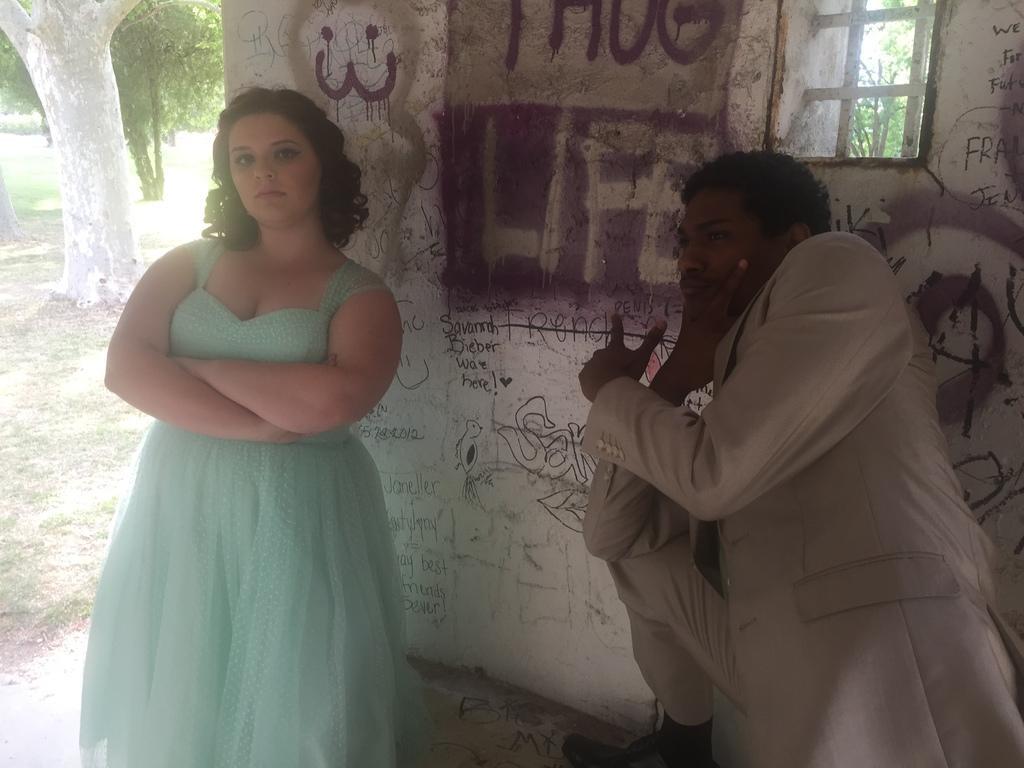Can you describe this image briefly? In this picture there are two people, behind these two people we can see text and painting on the wall and window. In the background of the image we can see trees and grass. 